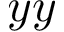<formula> <loc_0><loc_0><loc_500><loc_500>y y</formula> 